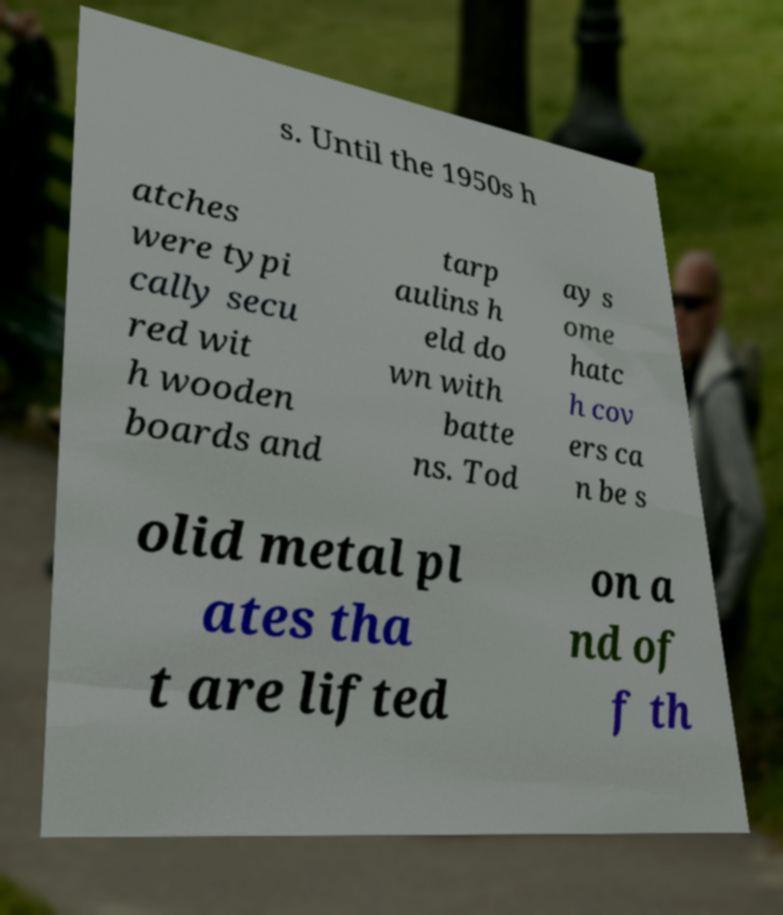Could you extract and type out the text from this image? s. Until the 1950s h atches were typi cally secu red wit h wooden boards and tarp aulins h eld do wn with batte ns. Tod ay s ome hatc h cov ers ca n be s olid metal pl ates tha t are lifted on a nd of f th 